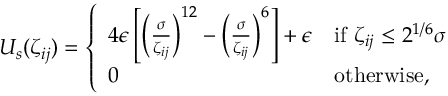Convert formula to latex. <formula><loc_0><loc_0><loc_500><loc_500>\begin{array} { r } { U _ { s } ( \zeta _ { i j } ) = \left \{ \begin{array} { l l } { 4 \epsilon \left [ \left ( \frac { \sigma } { \zeta _ { i j } } \right ) ^ { 1 2 } - \left ( \frac { \sigma } { \zeta _ { i j } } \right ) ^ { 6 } \right ] + \epsilon } & { i f \zeta _ { i j } \leq 2 ^ { 1 / 6 } \sigma } \\ { 0 } & { o t h e r w i s e , } \end{array} } \end{array}</formula> 